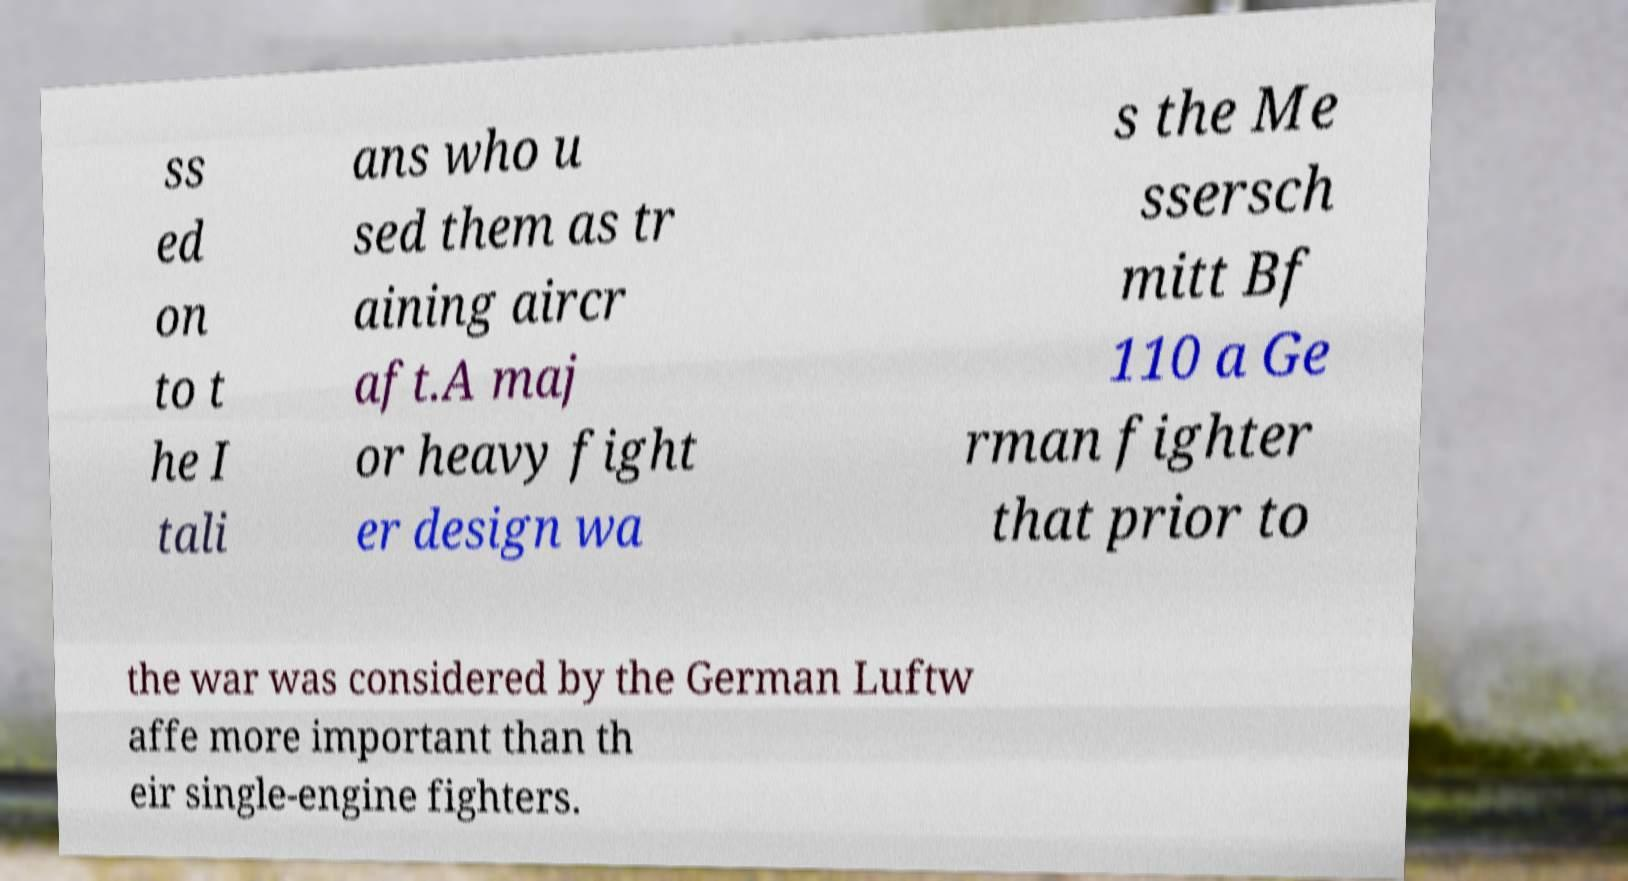Can you accurately transcribe the text from the provided image for me? ss ed on to t he I tali ans who u sed them as tr aining aircr aft.A maj or heavy fight er design wa s the Me ssersch mitt Bf 110 a Ge rman fighter that prior to the war was considered by the German Luftw affe more important than th eir single-engine fighters. 